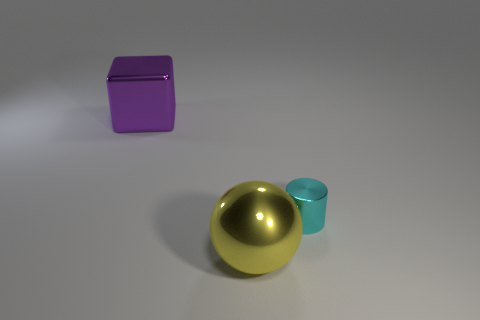How many things are either objects in front of the tiny cyan cylinder or things that are behind the yellow shiny ball?
Keep it short and to the point. 3. What is the color of the metallic cylinder?
Your answer should be compact. Cyan. Are there fewer large things that are in front of the block than gray cylinders?
Ensure brevity in your answer.  No. Is there any other thing that has the same shape as the tiny cyan object?
Your answer should be compact. No. Is there a gray metal thing?
Make the answer very short. No. Are there fewer big purple objects than purple rubber cubes?
Ensure brevity in your answer.  No. How many things are made of the same material as the purple block?
Give a very brief answer. 2. The large sphere that is made of the same material as the tiny cylinder is what color?
Provide a succinct answer. Yellow. The yellow metallic object has what shape?
Ensure brevity in your answer.  Sphere. There is another metal object that is the same size as the yellow metallic thing; what is its shape?
Provide a short and direct response. Cube. 